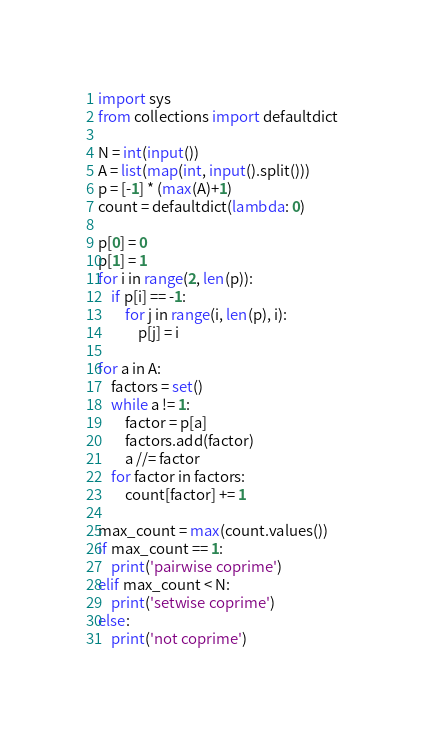<code> <loc_0><loc_0><loc_500><loc_500><_Python_>import sys
from collections import defaultdict

N = int(input())
A = list(map(int, input().split()))
p = [-1] * (max(A)+1)
count = defaultdict(lambda: 0)

p[0] = 0
p[1] = 1
for i in range(2, len(p)):
    if p[i] == -1:
        for j in range(i, len(p), i):
            p[j] = i

for a in A:
    factors = set()
    while a != 1:
        factor = p[a]
        factors.add(factor)
        a //= factor
    for factor in factors:
        count[factor] += 1

max_count = max(count.values())
if max_count == 1:
    print('pairwise coprime')
elif max_count < N:
    print('setwise coprime')
else:
    print('not coprime')
</code> 